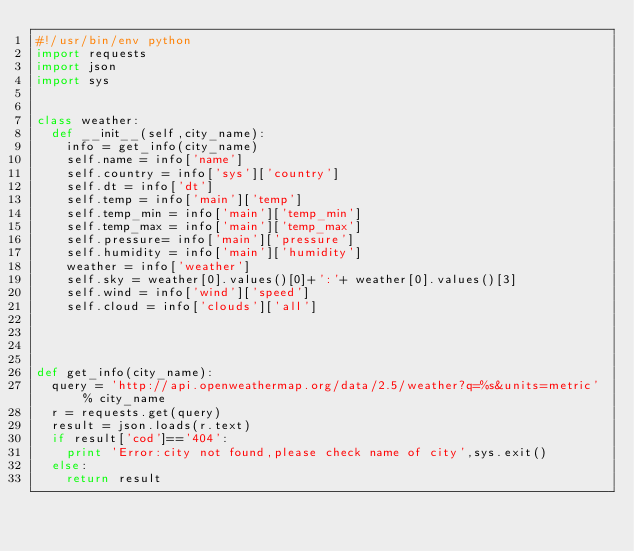Convert code to text. <code><loc_0><loc_0><loc_500><loc_500><_Python_>#!/usr/bin/env python
import requests
import json
import sys

 
class weather:
	def __init__(self,city_name):
		info = get_info(city_name)
		self.name = info['name']
		self.country = info['sys']['country']
		self.dt = info['dt']
		self.temp = info['main']['temp']
		self.temp_min = info['main']['temp_min']
		self.temp_max = info['main']['temp_max']
		self.pressure= info['main']['pressure']
		self.humidity = info['main']['humidity']
		weather = info['weather']
		self.sky = weather[0].values()[0]+':'+ weather[0].values()[3]
		self.wind = info['wind']['speed']
		self.cloud = info['clouds']['all']
		
		
		
		
def get_info(city_name):
	query = 'http://api.openweathermap.org/data/2.5/weather?q=%s&units=metric' % city_name
	r = requests.get(query)
	result = json.loads(r.text)
	if result['cod']=='404':
		print 'Error:city not found,please check name of city',sys.exit()
	else:
		return result

</code> 